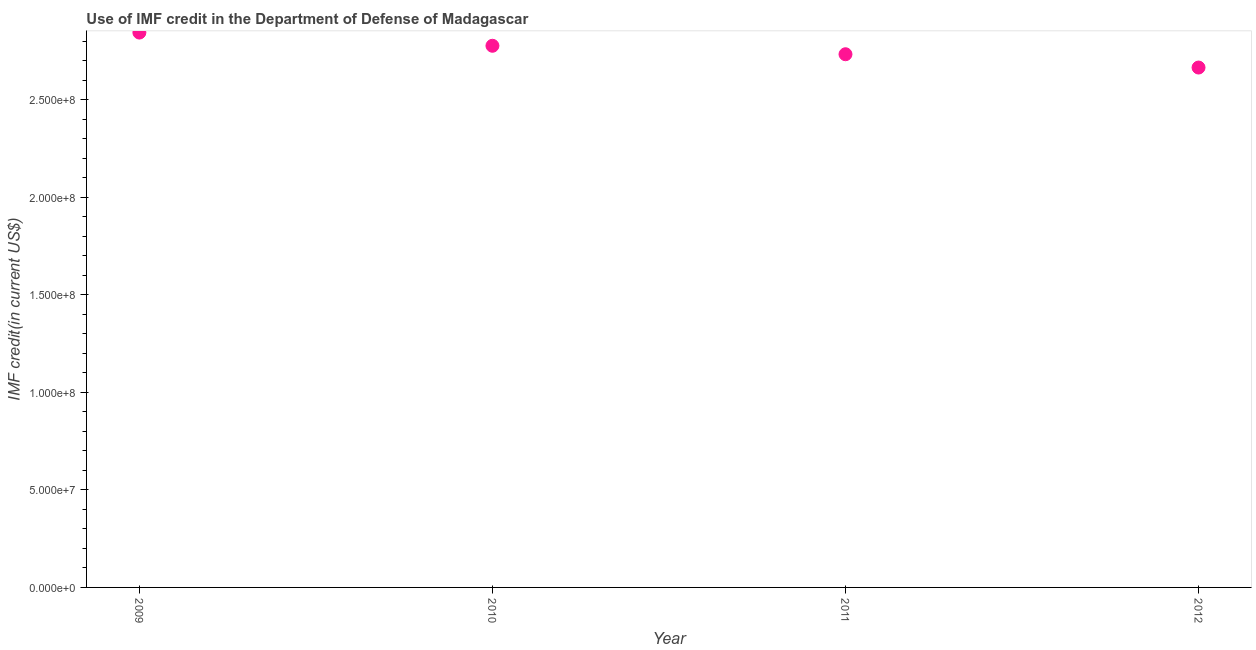What is the use of imf credit in dod in 2009?
Offer a terse response. 2.84e+08. Across all years, what is the maximum use of imf credit in dod?
Offer a very short reply. 2.84e+08. Across all years, what is the minimum use of imf credit in dod?
Make the answer very short. 2.67e+08. What is the sum of the use of imf credit in dod?
Provide a short and direct response. 1.10e+09. What is the difference between the use of imf credit in dod in 2009 and 2011?
Provide a succinct answer. 1.11e+07. What is the average use of imf credit in dod per year?
Give a very brief answer. 2.76e+08. What is the median use of imf credit in dod?
Your answer should be compact. 2.76e+08. In how many years, is the use of imf credit in dod greater than 100000000 US$?
Ensure brevity in your answer.  4. Do a majority of the years between 2011 and 2012 (inclusive) have use of imf credit in dod greater than 180000000 US$?
Offer a very short reply. Yes. What is the ratio of the use of imf credit in dod in 2011 to that in 2012?
Offer a very short reply. 1.03. Is the use of imf credit in dod in 2009 less than that in 2011?
Provide a succinct answer. No. Is the difference between the use of imf credit in dod in 2010 and 2011 greater than the difference between any two years?
Ensure brevity in your answer.  No. What is the difference between the highest and the second highest use of imf credit in dod?
Your answer should be compact. 6.77e+06. Is the sum of the use of imf credit in dod in 2009 and 2011 greater than the maximum use of imf credit in dod across all years?
Your response must be concise. Yes. What is the difference between the highest and the lowest use of imf credit in dod?
Keep it short and to the point. 1.79e+07. How many years are there in the graph?
Your answer should be compact. 4. What is the difference between two consecutive major ticks on the Y-axis?
Give a very brief answer. 5.00e+07. Does the graph contain grids?
Make the answer very short. No. What is the title of the graph?
Ensure brevity in your answer.  Use of IMF credit in the Department of Defense of Madagascar. What is the label or title of the Y-axis?
Provide a succinct answer. IMF credit(in current US$). What is the IMF credit(in current US$) in 2009?
Your answer should be very brief. 2.84e+08. What is the IMF credit(in current US$) in 2010?
Make the answer very short. 2.78e+08. What is the IMF credit(in current US$) in 2011?
Offer a very short reply. 2.73e+08. What is the IMF credit(in current US$) in 2012?
Make the answer very short. 2.67e+08. What is the difference between the IMF credit(in current US$) in 2009 and 2010?
Your answer should be very brief. 6.77e+06. What is the difference between the IMF credit(in current US$) in 2009 and 2011?
Keep it short and to the point. 1.11e+07. What is the difference between the IMF credit(in current US$) in 2009 and 2012?
Your answer should be very brief. 1.79e+07. What is the difference between the IMF credit(in current US$) in 2010 and 2011?
Provide a succinct answer. 4.34e+06. What is the difference between the IMF credit(in current US$) in 2010 and 2012?
Make the answer very short. 1.12e+07. What is the difference between the IMF credit(in current US$) in 2011 and 2012?
Your answer should be compact. 6.82e+06. What is the ratio of the IMF credit(in current US$) in 2009 to that in 2011?
Your answer should be compact. 1.04. What is the ratio of the IMF credit(in current US$) in 2009 to that in 2012?
Make the answer very short. 1.07. What is the ratio of the IMF credit(in current US$) in 2010 to that in 2012?
Your answer should be very brief. 1.04. What is the ratio of the IMF credit(in current US$) in 2011 to that in 2012?
Your answer should be compact. 1.03. 